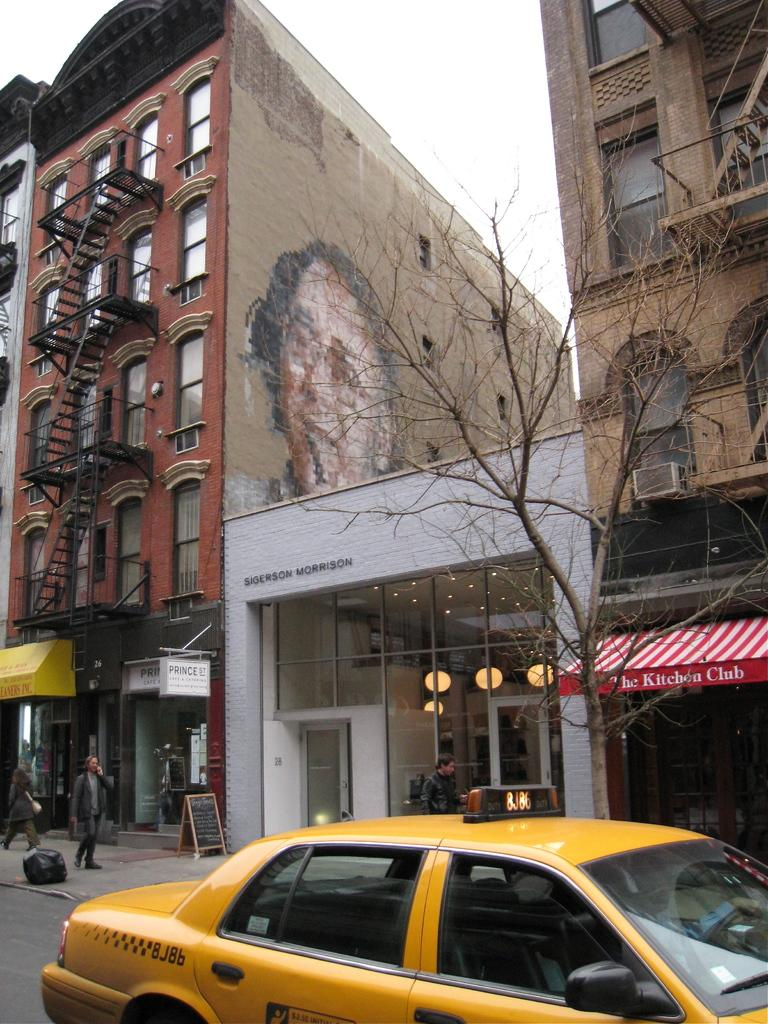<image>
Present a compact description of the photo's key features. A yellow taxi cab is driving past an establishment called The kitchen club with a red and white banner to entry. 